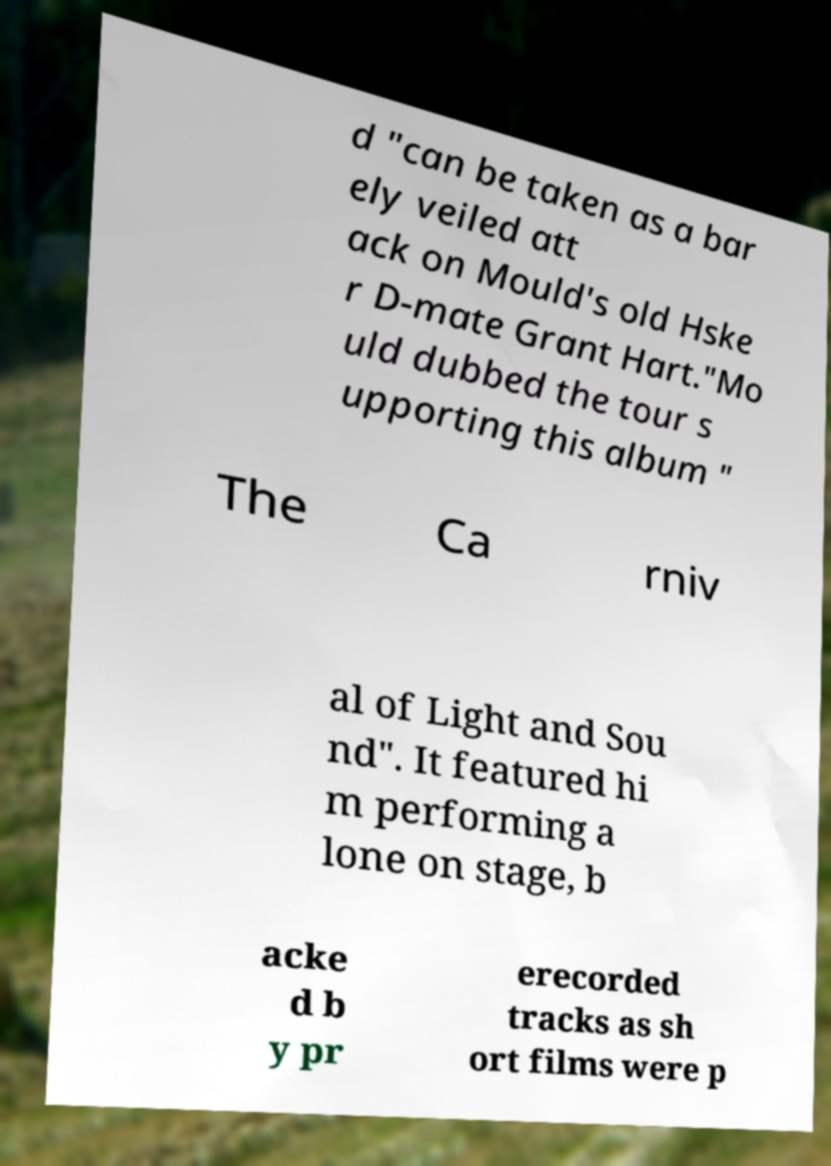Could you assist in decoding the text presented in this image and type it out clearly? d "can be taken as a bar ely veiled att ack on Mould's old Hske r D-mate Grant Hart."Mo uld dubbed the tour s upporting this album " The Ca rniv al of Light and Sou nd". It featured hi m performing a lone on stage, b acke d b y pr erecorded tracks as sh ort films were p 